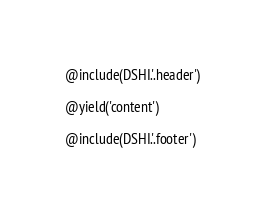Convert code to text. <code><loc_0><loc_0><loc_500><loc_500><_PHP_>@include(DSHI.'.header')

@yield('content')

@include(DSHI.'.footer')
</code> 